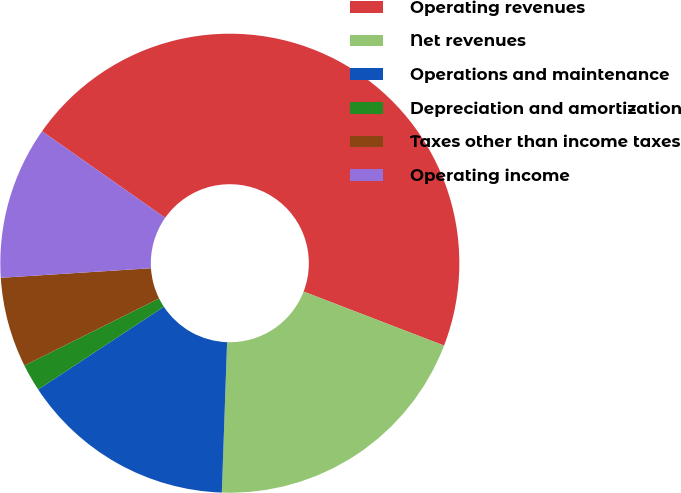Convert chart. <chart><loc_0><loc_0><loc_500><loc_500><pie_chart><fcel>Operating revenues<fcel>Net revenues<fcel>Operations and maintenance<fcel>Depreciation and amortization<fcel>Taxes other than income taxes<fcel>Operating income<nl><fcel>46.09%<fcel>19.71%<fcel>15.17%<fcel>1.92%<fcel>6.34%<fcel>10.76%<nl></chart> 